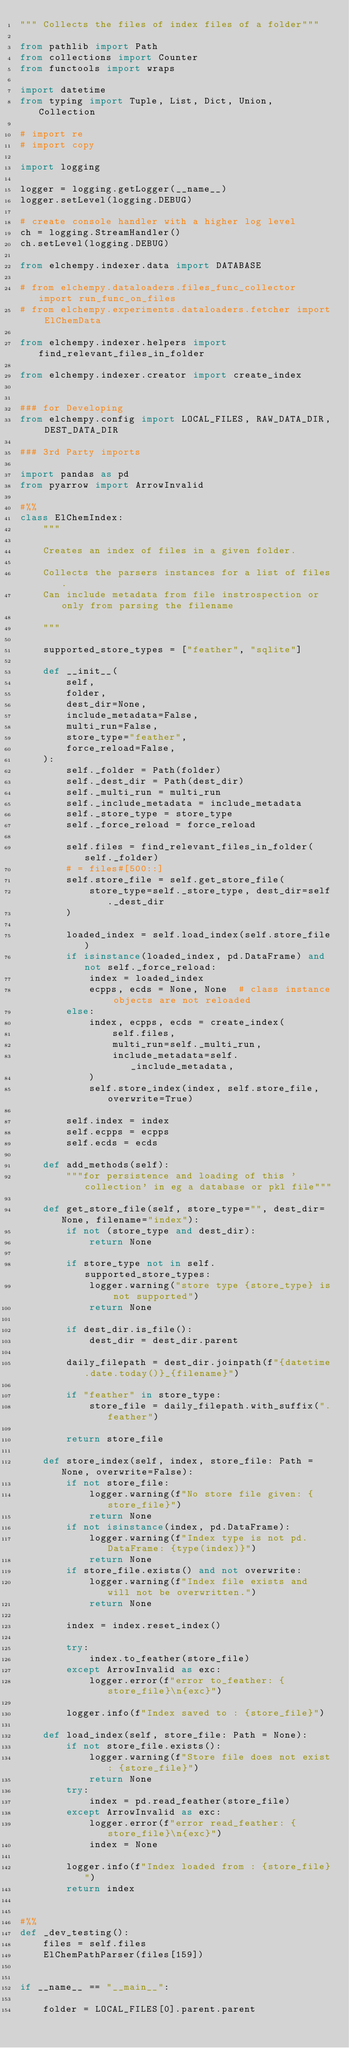Convert code to text. <code><loc_0><loc_0><loc_500><loc_500><_Python_>""" Collects the files of index files of a folder"""

from pathlib import Path
from collections import Counter
from functools import wraps

import datetime
from typing import Tuple, List, Dict, Union, Collection

# import re
# import copy

import logging

logger = logging.getLogger(__name__)
logger.setLevel(logging.DEBUG)

# create console handler with a higher log level
ch = logging.StreamHandler()
ch.setLevel(logging.DEBUG)

from elchempy.indexer.data import DATABASE

# from elchempy.dataloaders.files_func_collector import run_func_on_files
# from elchempy.experiments.dataloaders.fetcher import ElChemData

from elchempy.indexer.helpers import find_relevant_files_in_folder

from elchempy.indexer.creator import create_index


### for Developing
from elchempy.config import LOCAL_FILES, RAW_DATA_DIR, DEST_DATA_DIR

### 3rd Party imports

import pandas as pd
from pyarrow import ArrowInvalid

#%%
class ElChemIndex:
    """

    Creates an index of files in a given folder.

    Collects the parsers instances for a list of files.
    Can include metadata from file instrospection or only from parsing the filename

    """

    supported_store_types = ["feather", "sqlite"]

    def __init__(
        self,
        folder,
        dest_dir=None,
        include_metadata=False,
        multi_run=False,
        store_type="feather",
        force_reload=False,
    ):
        self._folder = Path(folder)
        self._dest_dir = Path(dest_dir)
        self._multi_run = multi_run
        self._include_metadata = include_metadata
        self._store_type = store_type
        self._force_reload = force_reload

        self.files = find_relevant_files_in_folder(self._folder)
        # = files#[500::]
        self.store_file = self.get_store_file(
            store_type=self._store_type, dest_dir=self._dest_dir
        )

        loaded_index = self.load_index(self.store_file)
        if isinstance(loaded_index, pd.DataFrame) and not self._force_reload:
            index = loaded_index
            ecpps, ecds = None, None  # class instance objects are not reloaded
        else:
            index, ecpps, ecds = create_index(
                self.files,
                multi_run=self._multi_run,
                include_metadata=self._include_metadata,
            )
            self.store_index(index, self.store_file, overwrite=True)

        self.index = index
        self.ecpps = ecpps
        self.ecds = ecds

    def add_methods(self):
        """for persistence and loading of this 'collection' in eg a database or pkl file"""

    def get_store_file(self, store_type="", dest_dir=None, filename="index"):
        if not (store_type and dest_dir):
            return None

        if store_type not in self.supported_store_types:
            logger.warning("store type {store_type} is not supported")
            return None

        if dest_dir.is_file():
            dest_dir = dest_dir.parent

        daily_filepath = dest_dir.joinpath(f"{datetime.date.today()}_{filename}")

        if "feather" in store_type:
            store_file = daily_filepath.with_suffix(".feather")

        return store_file

    def store_index(self, index, store_file: Path = None, overwrite=False):
        if not store_file:
            logger.warning(f"No store file given: {store_file}")
            return None
        if not isinstance(index, pd.DataFrame):
            logger.warning(f"Index type is not pd.DataFrame: {type(index)}")
            return None
        if store_file.exists() and not overwrite:
            logger.warning(f"Index file exists and will not be overwritten.")
            return None

        index = index.reset_index()

        try:
            index.to_feather(store_file)
        except ArrowInvalid as exc:
            logger.error(f"error to_feather: {store_file}\n{exc}")

        logger.info(f"Index saved to : {store_file}")

    def load_index(self, store_file: Path = None):
        if not store_file.exists():
            logger.warning(f"Store file does not exist: {store_file}")
            return None
        try:
            index = pd.read_feather(store_file)
        except ArrowInvalid as exc:
            logger.error(f"error read_feather: {store_file}\n{exc}")
            index = None

        logger.info(f"Index loaded from : {store_file}")
        return index


#%%
def _dev_testing():
    files = self.files
    ElChemPathParser(files[159])


if __name__ == "__main__":

    folder = LOCAL_FILES[0].parent.parent</code> 